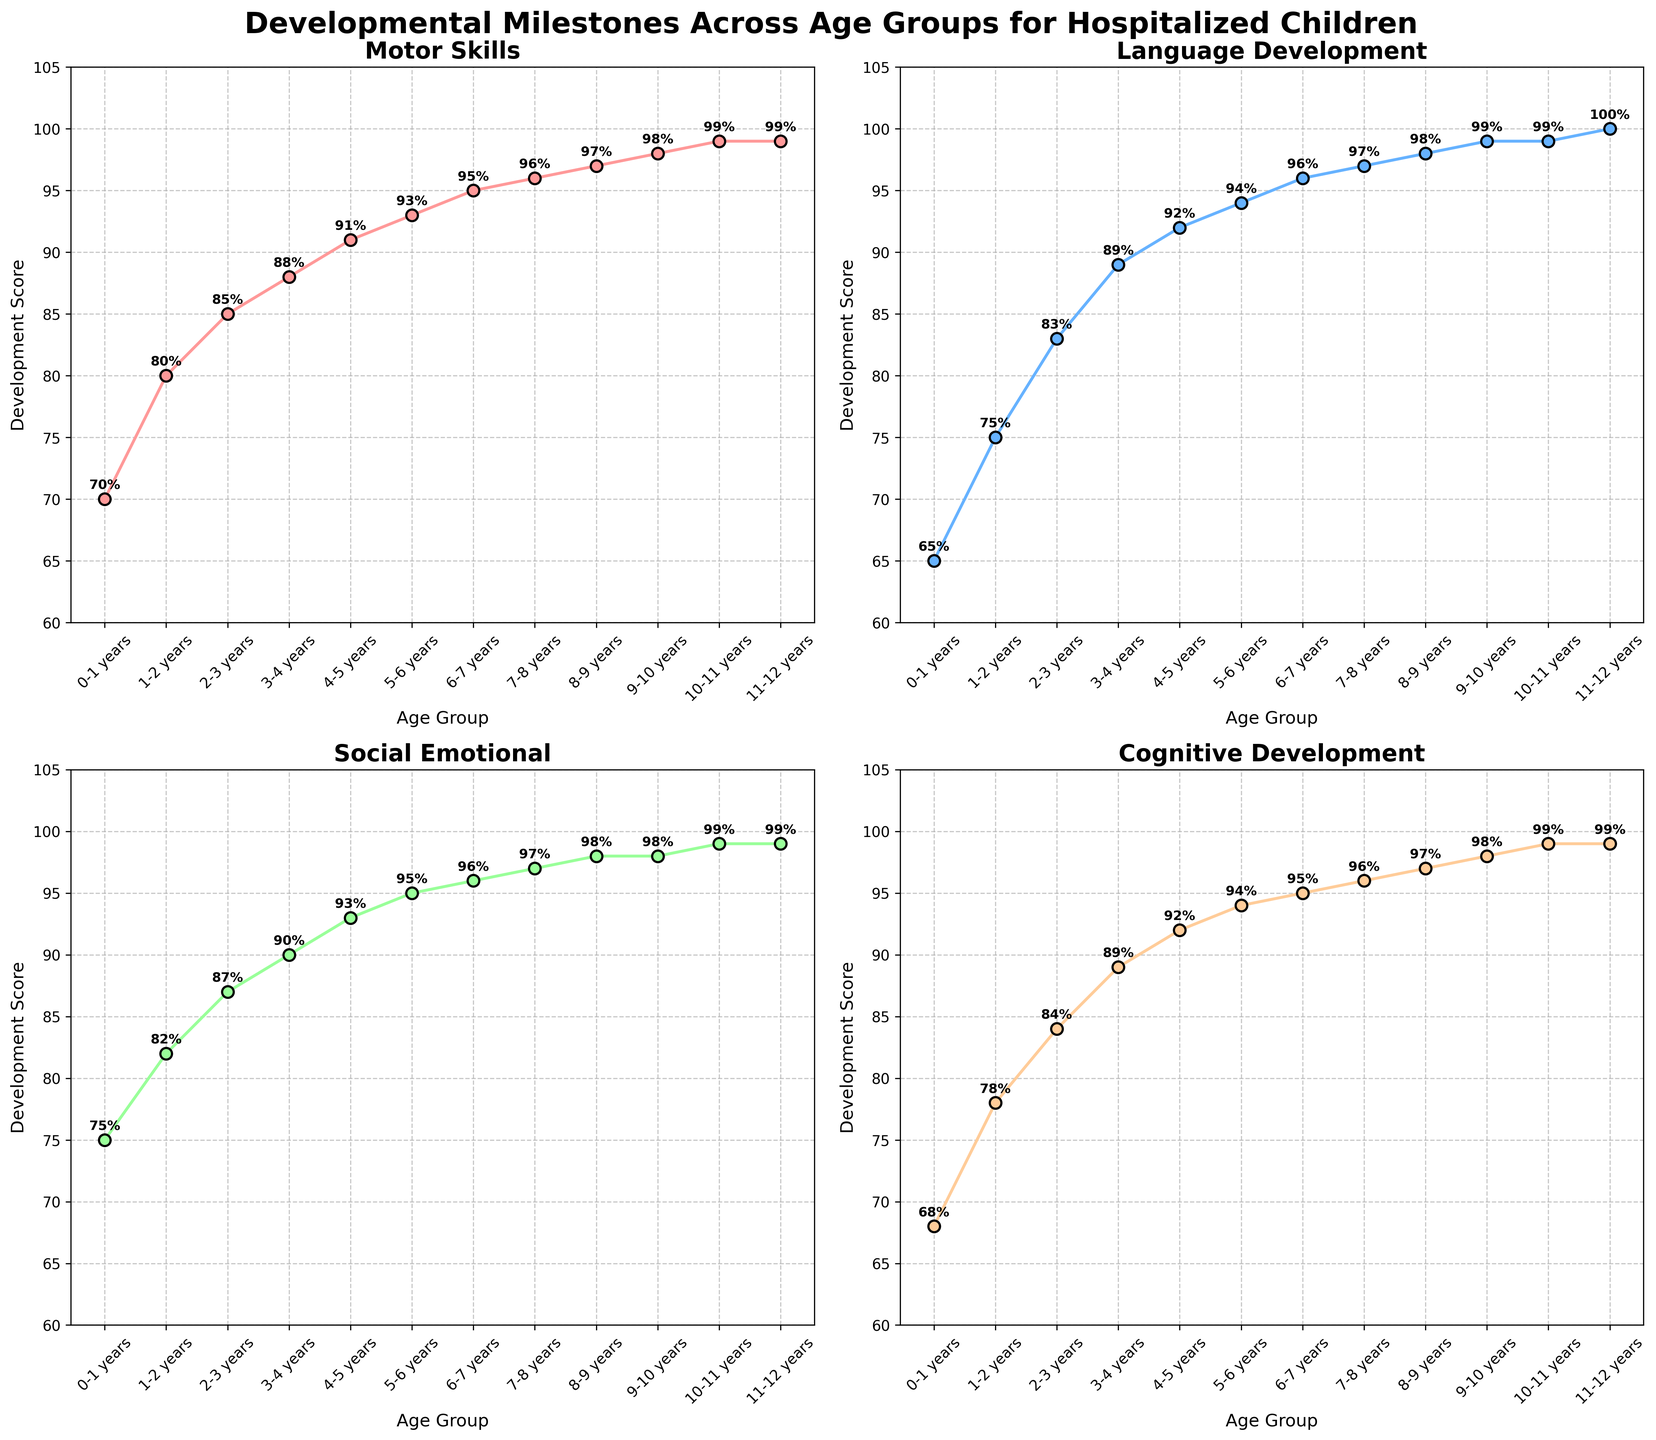Which age group shows the highest development score in Motor Skills? Looking at the first subplot for Motor Skills, observe that the highest score (99%) is in the age group 11-12 years.
Answer: 11-12 years What is the difference in Cognitive Development scores between the age groups 3-4 years and 8-9 years? Refer to the subplot for Cognitive Development. The score for 3-4 years is 89%, and for 8-9 years it is 97%. The difference is 97% - 89% = 8%.
Answer: 8 Which developmental category shows a more significant increase from 0-1 years to 2-3 years: Motor Skills or Language Development? For Motor Skills, the scores are 70% and 85%, increasing by 15%. For Language Development, the scores are 65% and 83%, increasing by 18%. Therefore, Language Development shows a more significant increase.
Answer: Language Development Do Social-Emotional scores ever reach 100% across the age groups? Observe the subplot for Social-Emotional development. The highest value is 99%, but it never reaches 100%.
Answer: No What is the average development score for the age group 6-7 years across all categories? The scores for 6-7 years are: 95% for Motor Skills, 96% for Language Development, 96% for Social-Emotional, and 95% for Cognitive Development. The average is (95 + 96 + 96 + 95)/4 = 95.5%.
Answer: 95.5 Compare the Cognitive Development score of 2-3 years with the Motor Skills score of 7-8 years. Which one is higher? Look at the subplots for Cognitive Development and Motor Skills. The score for Cognitive Development of 2-3 years is 84%, and the score for Motor Skills of 7-8 years is 96%. The latter is higher.
Answer: Motor Skills of 7-8 years Is there any age group where all developmental categories have the same score? Check if there's an age group where the scores in all subplots are identical. The 11-12 years group has 99% in all categories.
Answer: 11-12 years What is the combined increase in Social-Emotional Development scores from age 1-2 years to 11-12 years? The scores are 82% for 1-2 years and 99% for 11-12 years. The increase is 99% - 82% = 17%.
Answer: 17 Which developmental category has the highest development score at the age group 9-10 years? For 9-10 years, the scores are 98% for Motor Skills, 99% for Language Development, 98% for Social-Emotional, and 98% for Cognitive Development. The highest score is in Language Development.
Answer: Language Development 